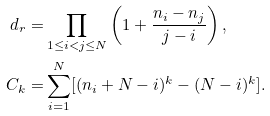Convert formula to latex. <formula><loc_0><loc_0><loc_500><loc_500>d _ { r } = & \prod _ { 1 \leq i < j \leq N } \left ( 1 + \frac { n _ { i } - n _ { j } } { j - i } \right ) , \\ C _ { k } = & \sum _ { i = 1 } ^ { N } [ ( n _ { i } + N - i ) ^ { k } - ( N - i ) ^ { k } ] .</formula> 